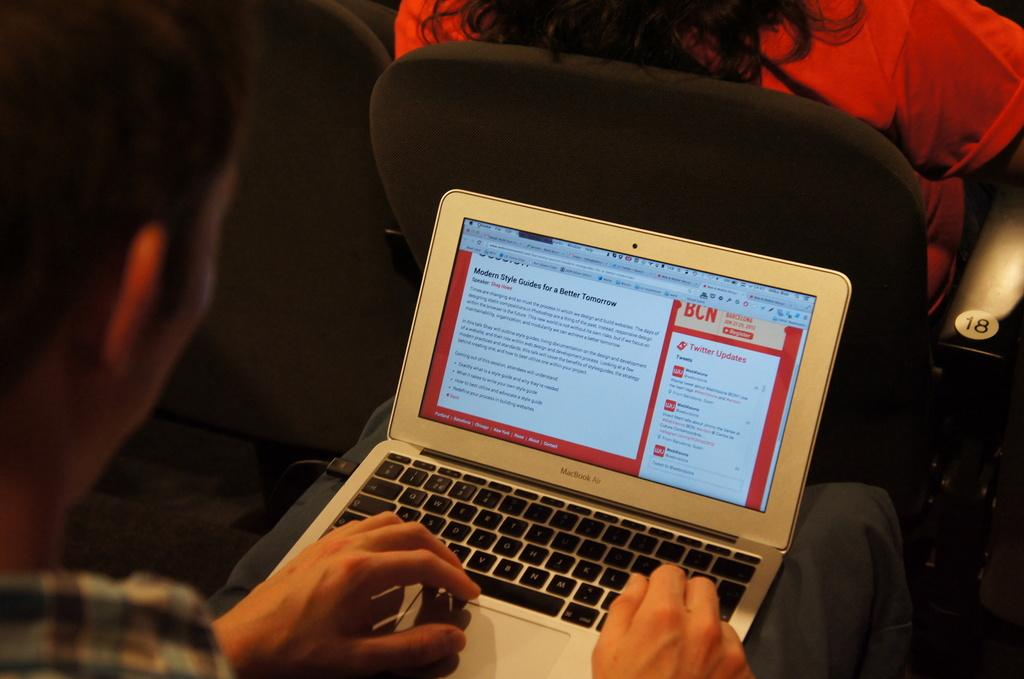What electronic device is visible in the image? There is a laptop in the image. Where is the laptop located? The laptop is on the lap of a person. Can you describe the person using the laptop? The person using the laptop is a woman. What is the woman sitting on in the image? The woman is sitting on a chair. What additional detail can be observed about the chair? There is a number visible on the chair. What type of education is being offered at the market in the image? There is no market or education present in the image; it features a woman with a laptop on her lap while sitting on a chair. 